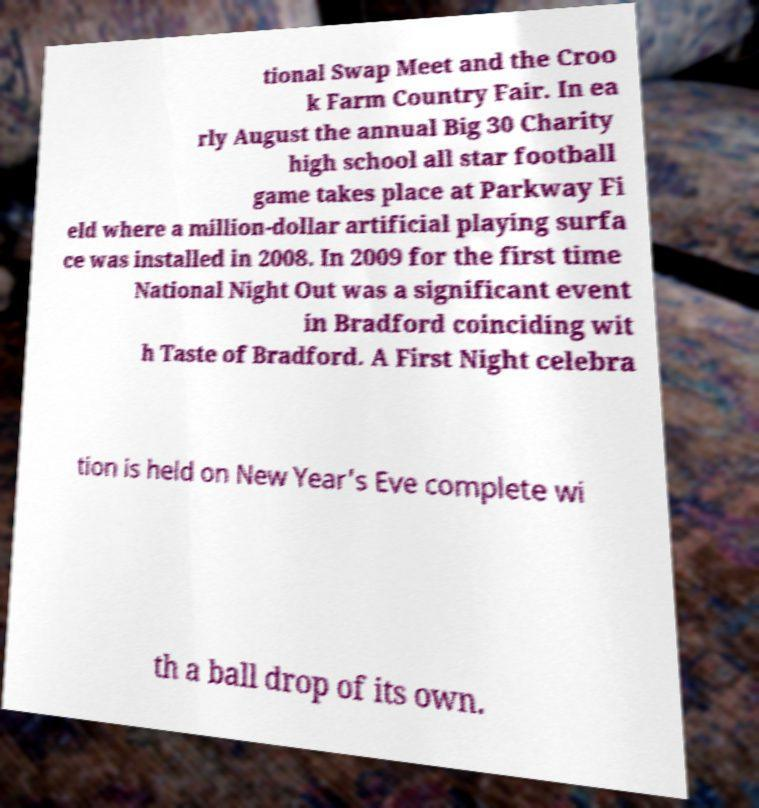Can you accurately transcribe the text from the provided image for me? tional Swap Meet and the Croo k Farm Country Fair. In ea rly August the annual Big 30 Charity high school all star football game takes place at Parkway Fi eld where a million-dollar artificial playing surfa ce was installed in 2008. In 2009 for the first time National Night Out was a significant event in Bradford coinciding wit h Taste of Bradford. A First Night celebra tion is held on New Year's Eve complete wi th a ball drop of its own. 